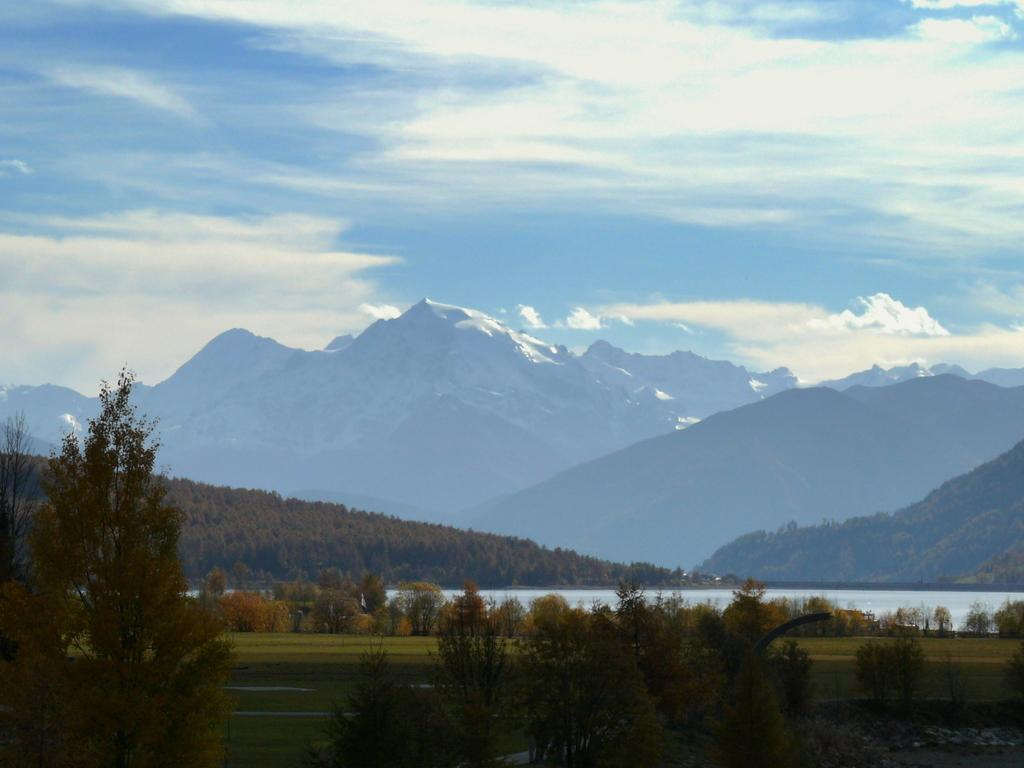What type of vegetation is present in the image? There are trees in the image. What can be seen in the foreground of the image? There appears to be water and grassland in the foreground of the image. What is visible in the background of the image? There are mountains and the sky in the background of the image. How many chickens are perched on the engine in the image? There is no engine or chickens present in the image. What type of neck accessory is visible on the trees in the image? There are no neck accessories present on the trees in the image; they are simply trees. 